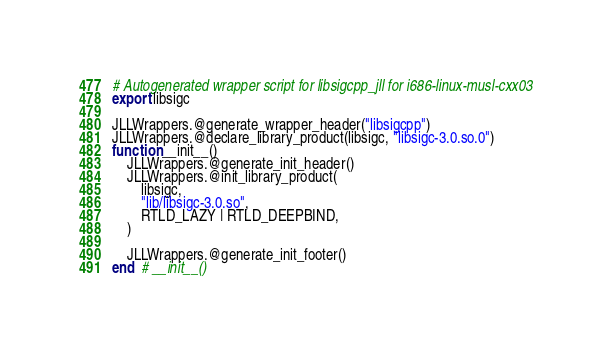Convert code to text. <code><loc_0><loc_0><loc_500><loc_500><_Julia_># Autogenerated wrapper script for libsigcpp_jll for i686-linux-musl-cxx03
export libsigc

JLLWrappers.@generate_wrapper_header("libsigcpp")
JLLWrappers.@declare_library_product(libsigc, "libsigc-3.0.so.0")
function __init__()
    JLLWrappers.@generate_init_header()
    JLLWrappers.@init_library_product(
        libsigc,
        "lib/libsigc-3.0.so",
        RTLD_LAZY | RTLD_DEEPBIND,
    )

    JLLWrappers.@generate_init_footer()
end  # __init__()
</code> 